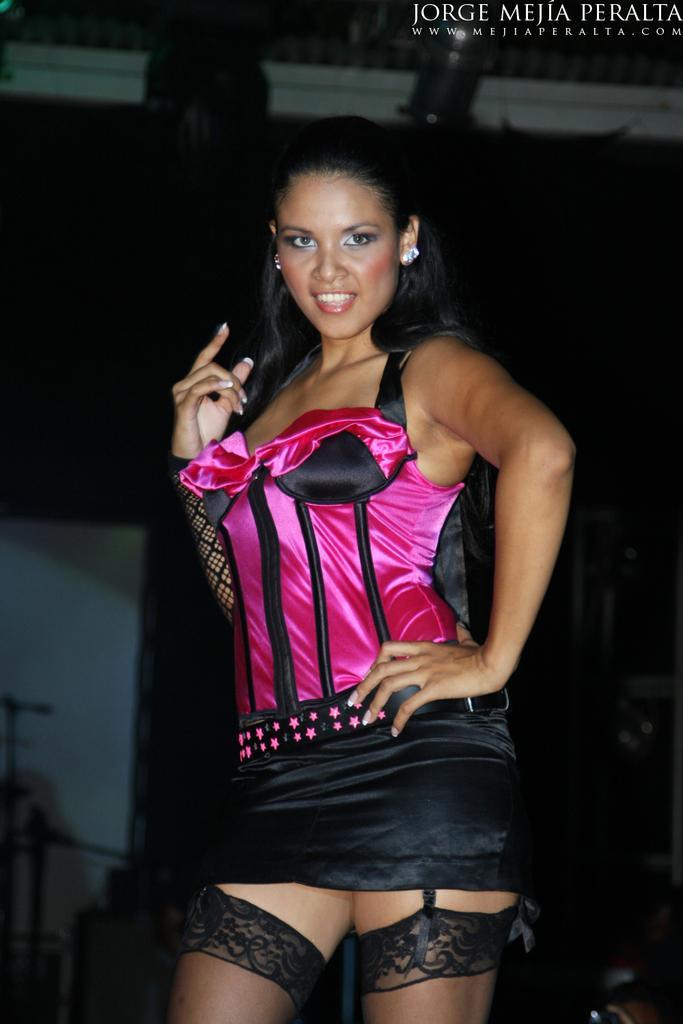Please provide a concise description of this image. In this picture there is a woman with pink and black dress is stunning. At the back there are microphones and there are objects and their might be a curtain. At the top there are lights. At the top right there is text. 